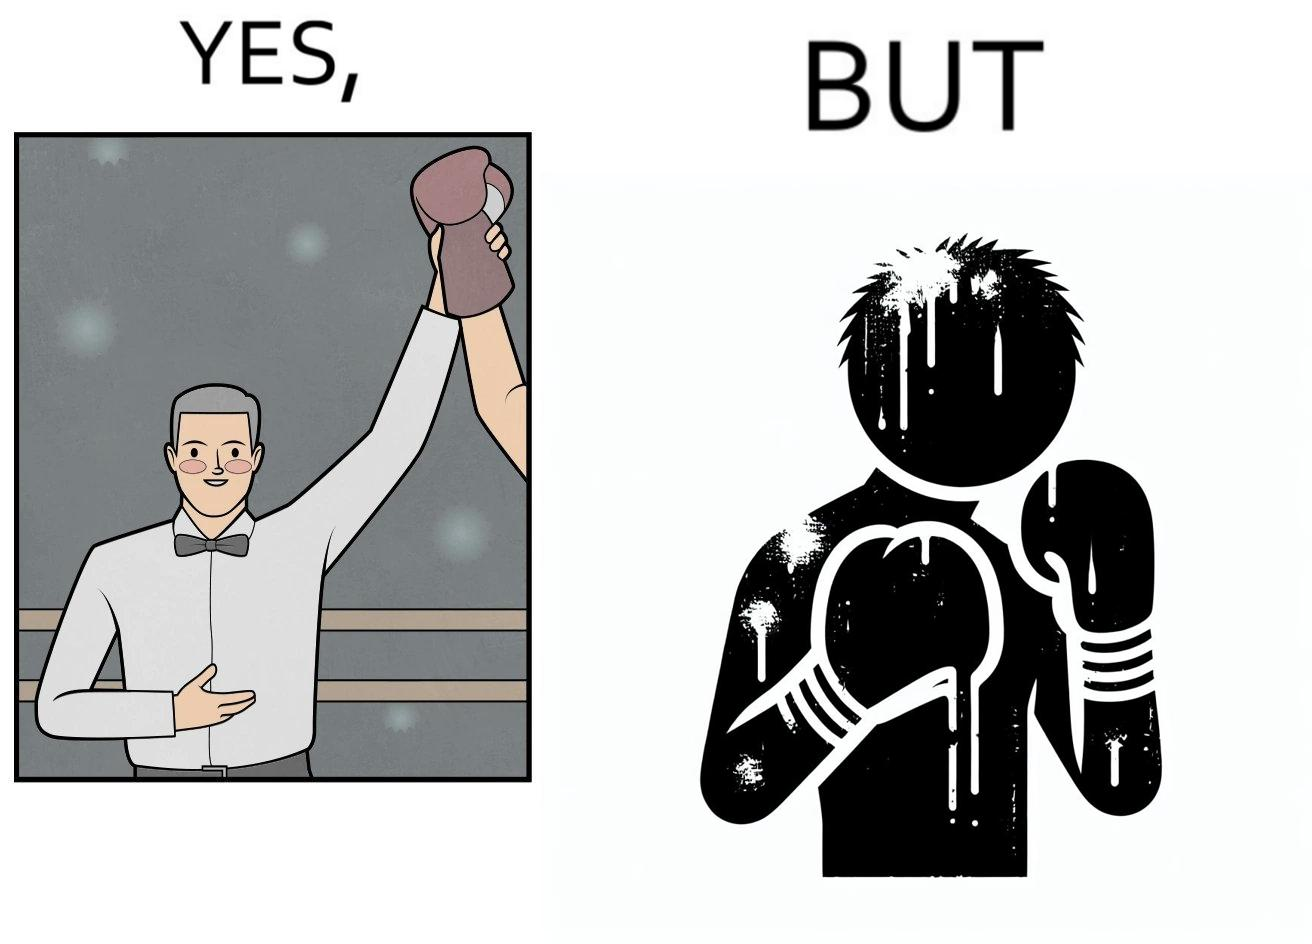Would you classify this image as satirical? Yes, this image is satirical. 